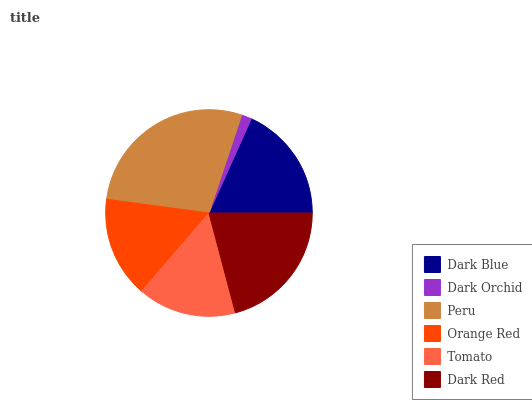Is Dark Orchid the minimum?
Answer yes or no. Yes. Is Peru the maximum?
Answer yes or no. Yes. Is Peru the minimum?
Answer yes or no. No. Is Dark Orchid the maximum?
Answer yes or no. No. Is Peru greater than Dark Orchid?
Answer yes or no. Yes. Is Dark Orchid less than Peru?
Answer yes or no. Yes. Is Dark Orchid greater than Peru?
Answer yes or no. No. Is Peru less than Dark Orchid?
Answer yes or no. No. Is Dark Blue the high median?
Answer yes or no. Yes. Is Orange Red the low median?
Answer yes or no. Yes. Is Orange Red the high median?
Answer yes or no. No. Is Dark Blue the low median?
Answer yes or no. No. 